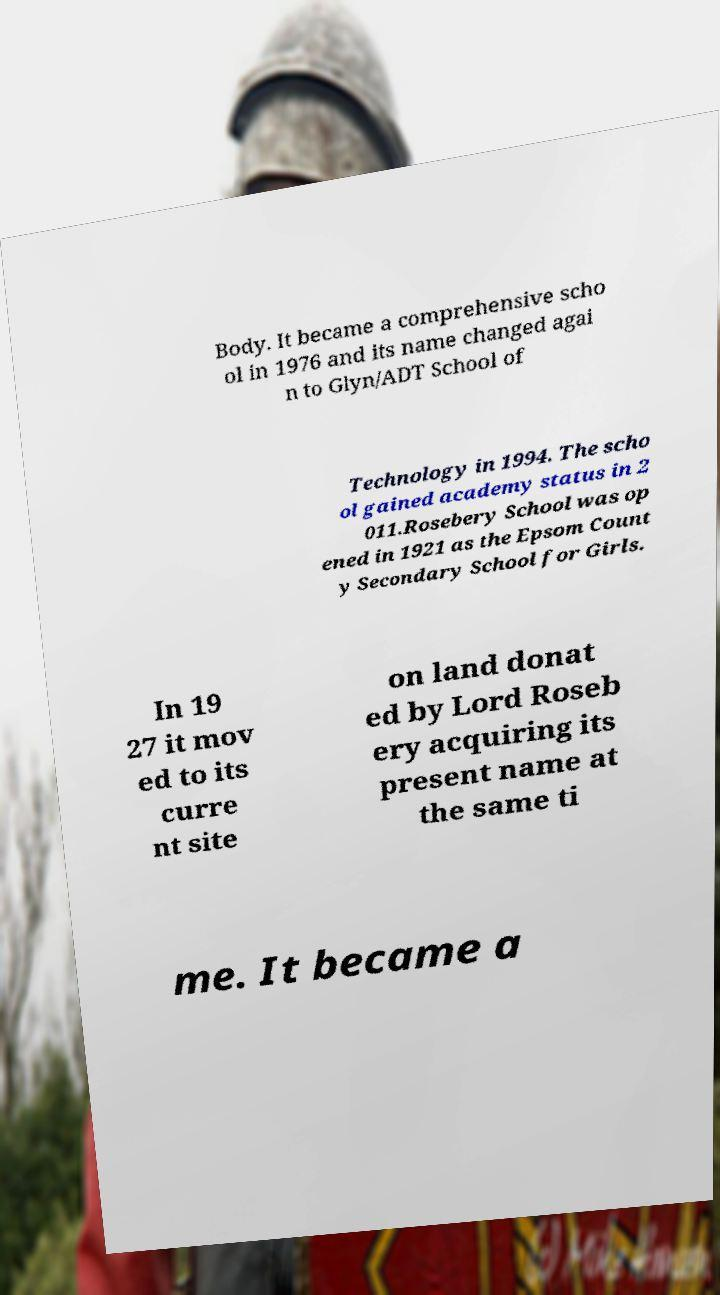Please read and relay the text visible in this image. What does it say? Body. It became a comprehensive scho ol in 1976 and its name changed agai n to Glyn/ADT School of Technology in 1994. The scho ol gained academy status in 2 011.Rosebery School was op ened in 1921 as the Epsom Count y Secondary School for Girls. In 19 27 it mov ed to its curre nt site on land donat ed by Lord Roseb ery acquiring its present name at the same ti me. It became a 